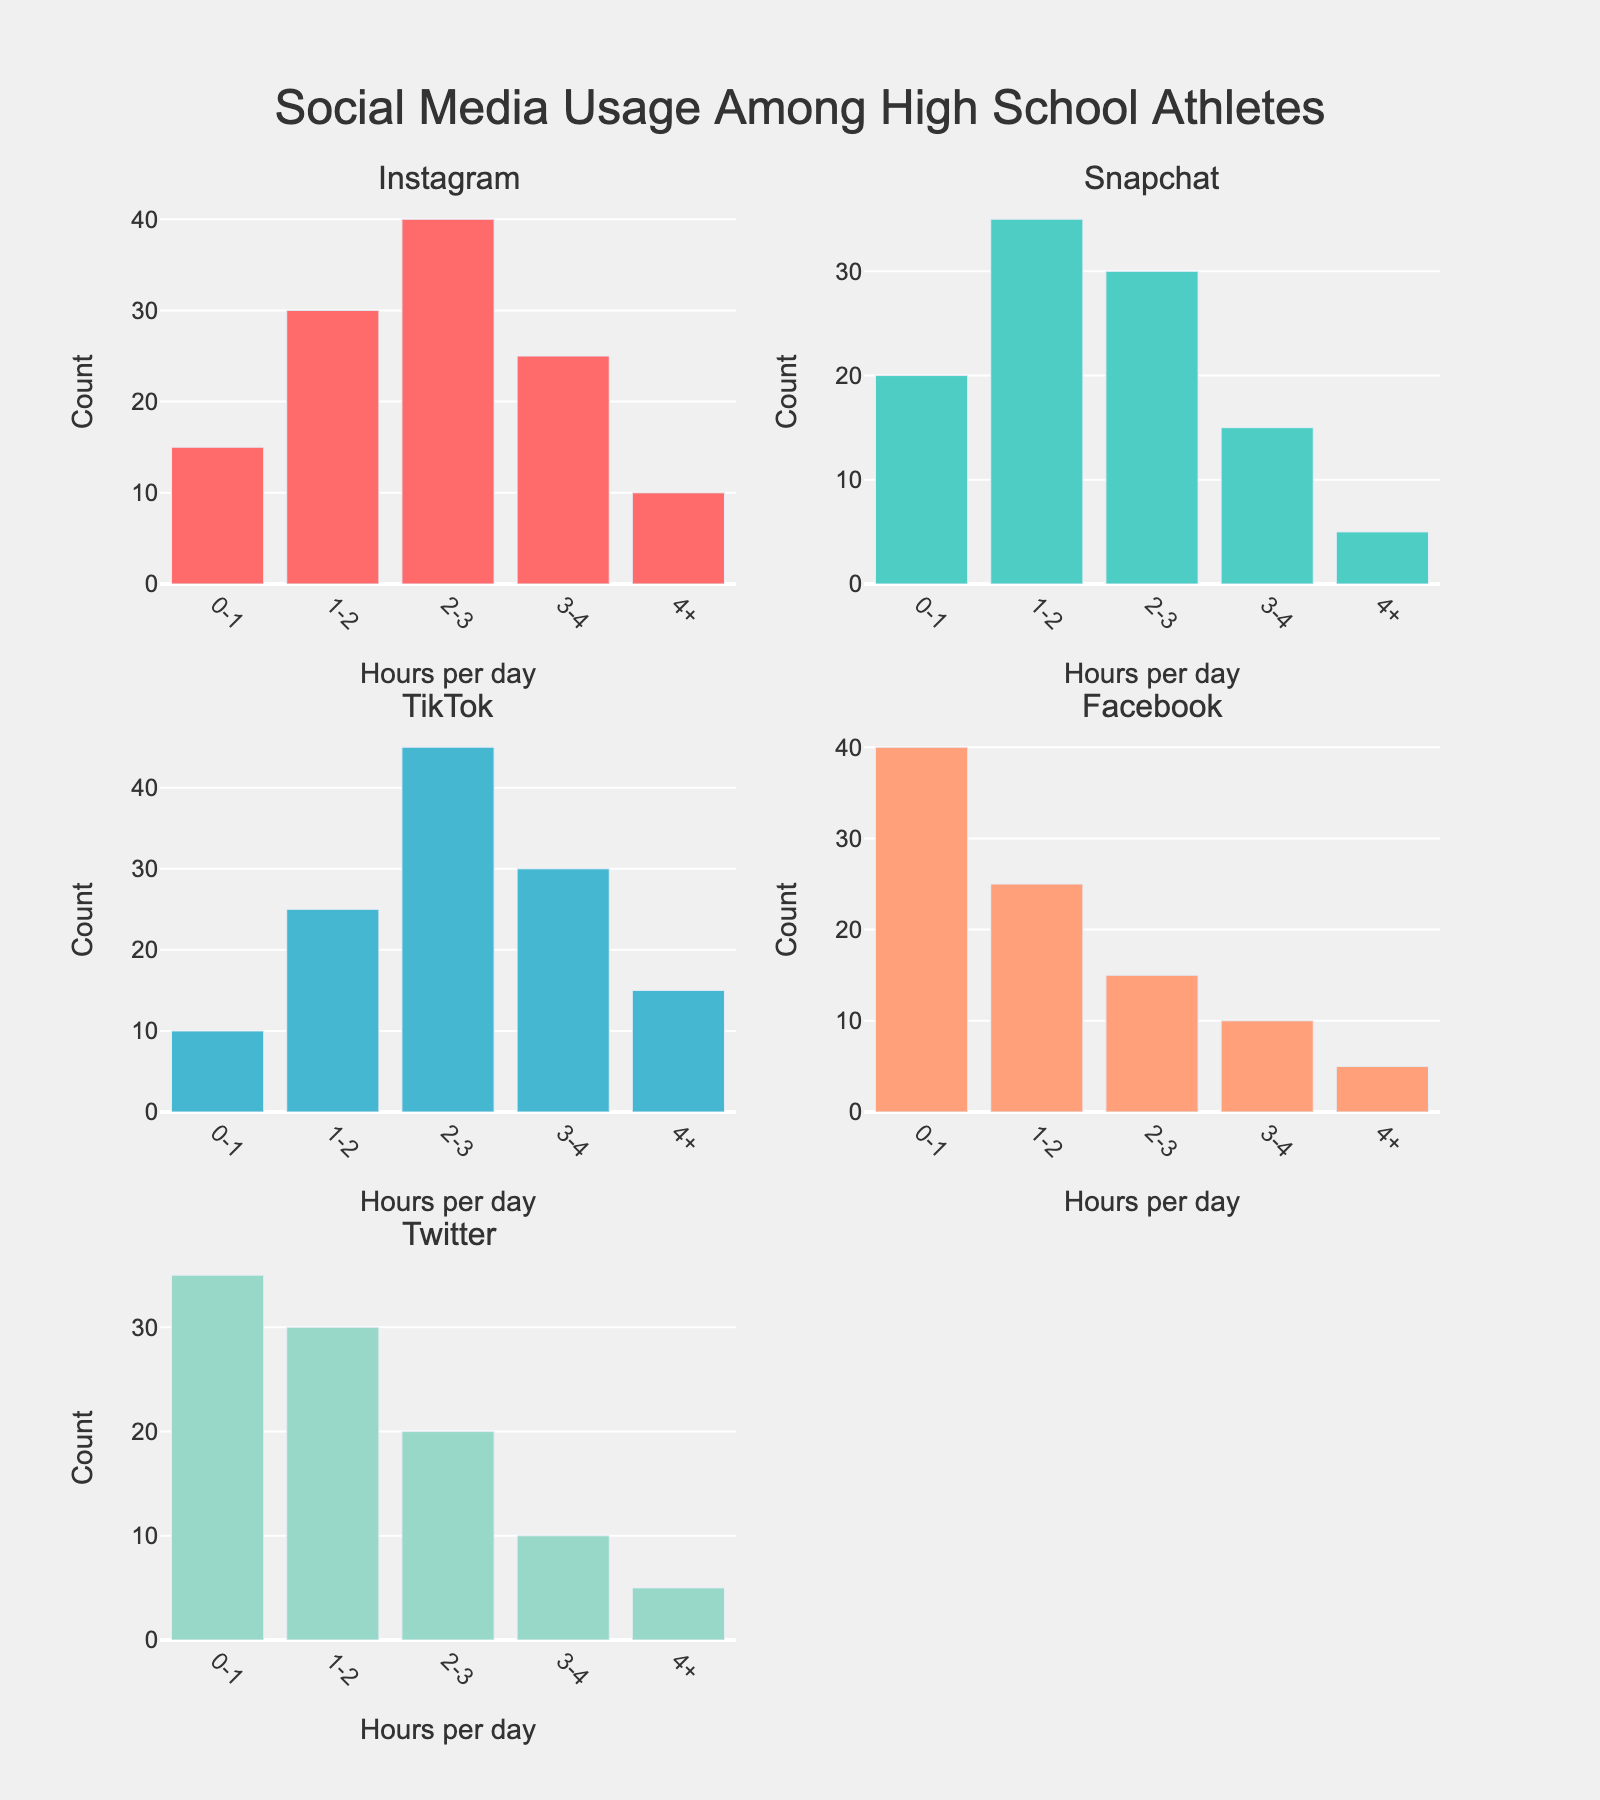How many hours per day do most high school athletes spend on Instagram? By examining the count of bars in the Instagram subplot, the highest bar represents usage of 2-3 hours per day. This bar reaches 40, which is the highest count among all the bars for Instagram.
Answer: 2-3 hours Which social media platform has the highest frequency of 4+ hours of usage per day? By comparing the heights of the bars labeled "4+" across all platforms, we notice that TikTok has the tallest bar, reaching a count of 15.
Answer: TikTok How many high school athletes spend 1-2 hours per day on Snapchat? In the Snapchat subplot, the bar representing 1-2 hours per day reaches a count of 35.
Answer: 35 Which platform has the least frequent usage of 0-1 hours per day? By comparing the bars labeled "0-1" across all platforms, TikTok has the shortest bar with a count of 10.
Answer: TikTok What is the total number of high school athletes using Twitter for more than 2 hours per day combined? Summing the counts of the bars labeled "2-3", "3-4", and "4+" in the Twitter subplot: 20 + 10 + 5 = 35.
Answer: 35 On which platform do the most high school athletes spend less than 2 hours per day combined? Summing the counts of the bars labeled "0-1" and "1-2" for each platform, Facebook has the highest total: 40 + 25 = 65.
Answer: Facebook Is Facebook's 0-1 hours per day usage higher than TikTok's 2-3 hours per day usage? The bar representing 0-1 hours per day on Facebook reaches a count of 40, whereas the 2-3 hours per day bar on TikTok reaches a count of 45. 45 is greater than 40.
Answer: No Which platform has the most diverse usage pattern, indicated by the range of hours per day? By observing the variability in the heights of bars for each platform, Instagram and TikTok have a diverse distribution of usage across the different time intervals. Both have notable differences across all hour categories.
Answer: Instagram and TikTok Which two time intervals collectively account for the highest count on Instagram? By summing the counts of all intervals, the 1-2 and 2-3 categories for Instagram are: 30 + 40 = 70.
Answer: 1-2 and 2-3 What percentage of high school athletes use Twitter for 0-1 hours per day? The total count for Twitter is summed by adding all the Twitter bars: 35 + 30 + 20 + 10 + 5 = 100. The 0-1 hours count is 35. The percentage is (35/100) * 100 = 35%.
Answer: 35% 